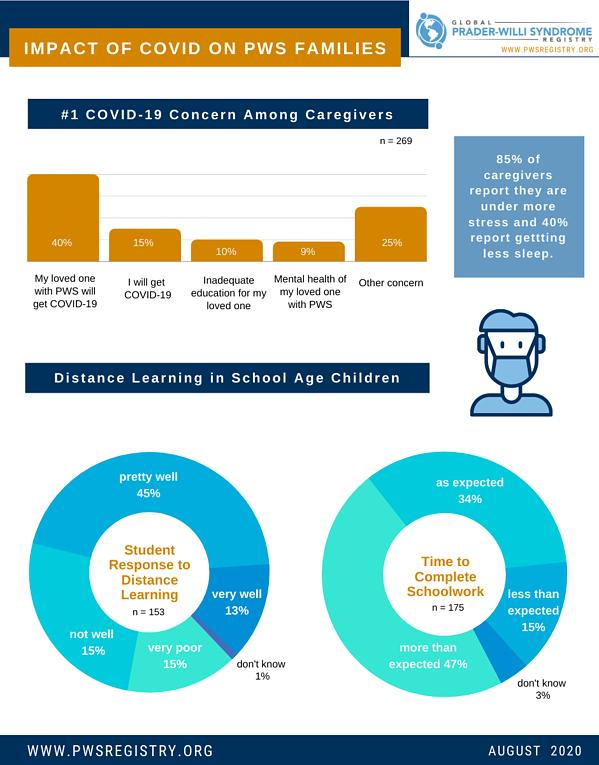Indicate a few pertinent items in this graphic. In August 2020, it was found that 15% of school-age children had less than the expected amount of time to complete their schoolwork, indicating a potential issue with their academic progress. According to a survey conducted in August 2020, 15% of caregivers reported being concerned that they might contract COVID-19. In August 2020, it was found that 13% of school-age children demonstrated a highly favorable response to distance learning. According to a recent survey conducted in August 2020, it was found that 10% of caregivers are concerned about the inadequate education of their loved ones due to the impact of COVID-19. According to available data, as of August 2020, approximately 15% of school-age children have a poor response to distance learning. 